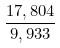Convert formula to latex. <formula><loc_0><loc_0><loc_500><loc_500>\frac { 1 7 , 8 0 4 } { 9 , 9 3 3 }</formula> 